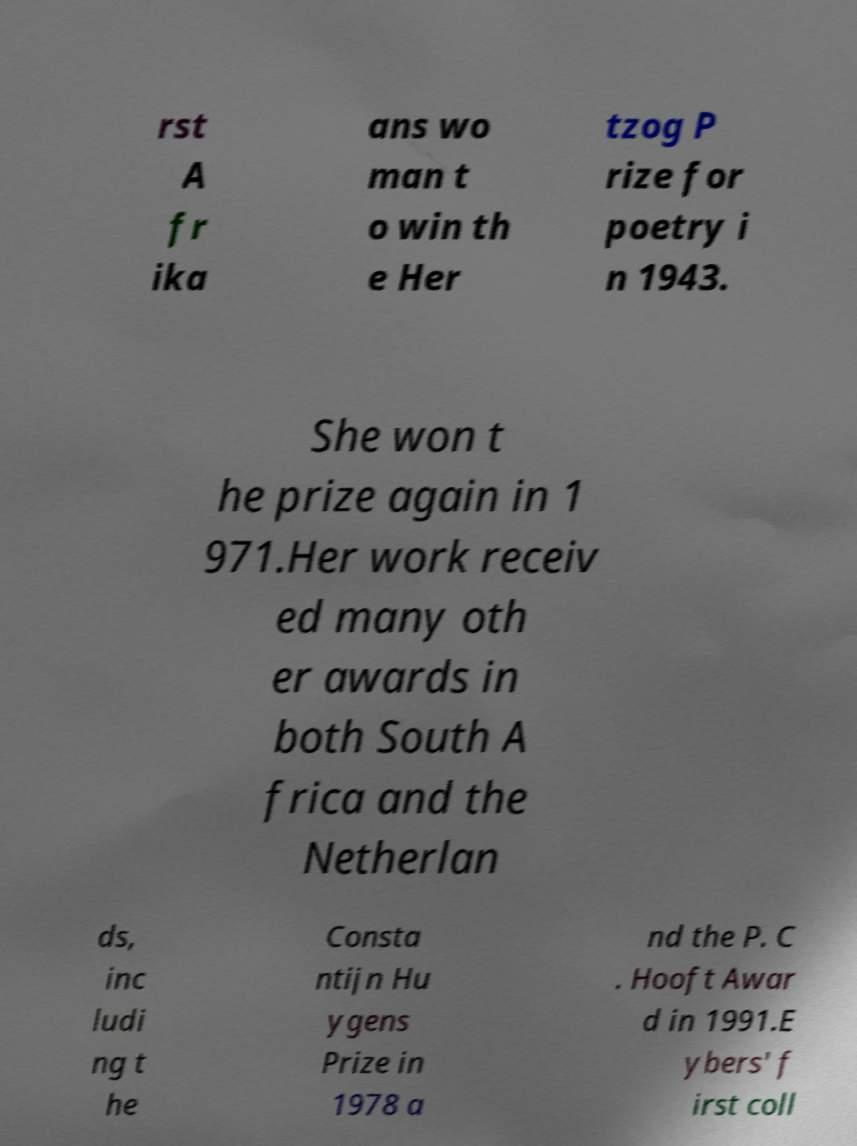I need the written content from this picture converted into text. Can you do that? rst A fr ika ans wo man t o win th e Her tzog P rize for poetry i n 1943. She won t he prize again in 1 971.Her work receiv ed many oth er awards in both South A frica and the Netherlan ds, inc ludi ng t he Consta ntijn Hu ygens Prize in 1978 a nd the P. C . Hooft Awar d in 1991.E ybers' f irst coll 